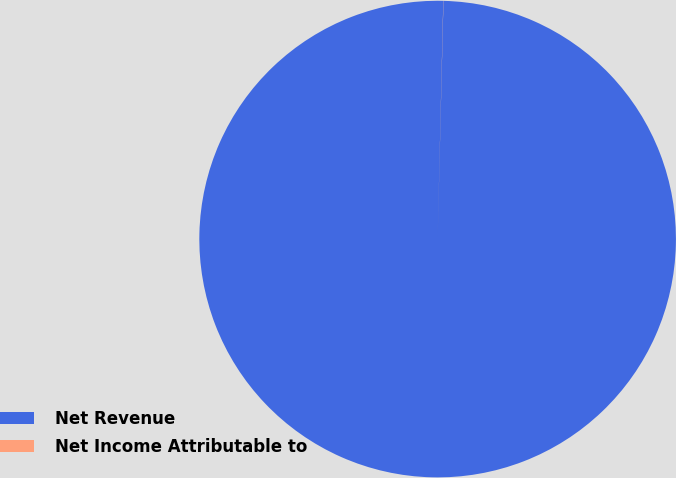Convert chart. <chart><loc_0><loc_0><loc_500><loc_500><pie_chart><fcel>Net Revenue<fcel>Net Income Attributable to<nl><fcel>99.99%<fcel>0.01%<nl></chart> 